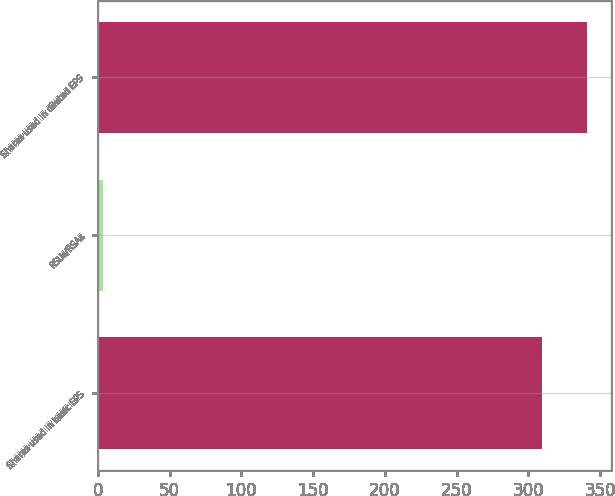<chart> <loc_0><loc_0><loc_500><loc_500><bar_chart><fcel>Shares used in basic EPS<fcel>RSUs/RSAs<fcel>Shares used in diluted EPS<nl><fcel>309.2<fcel>3.2<fcel>340.51<nl></chart> 